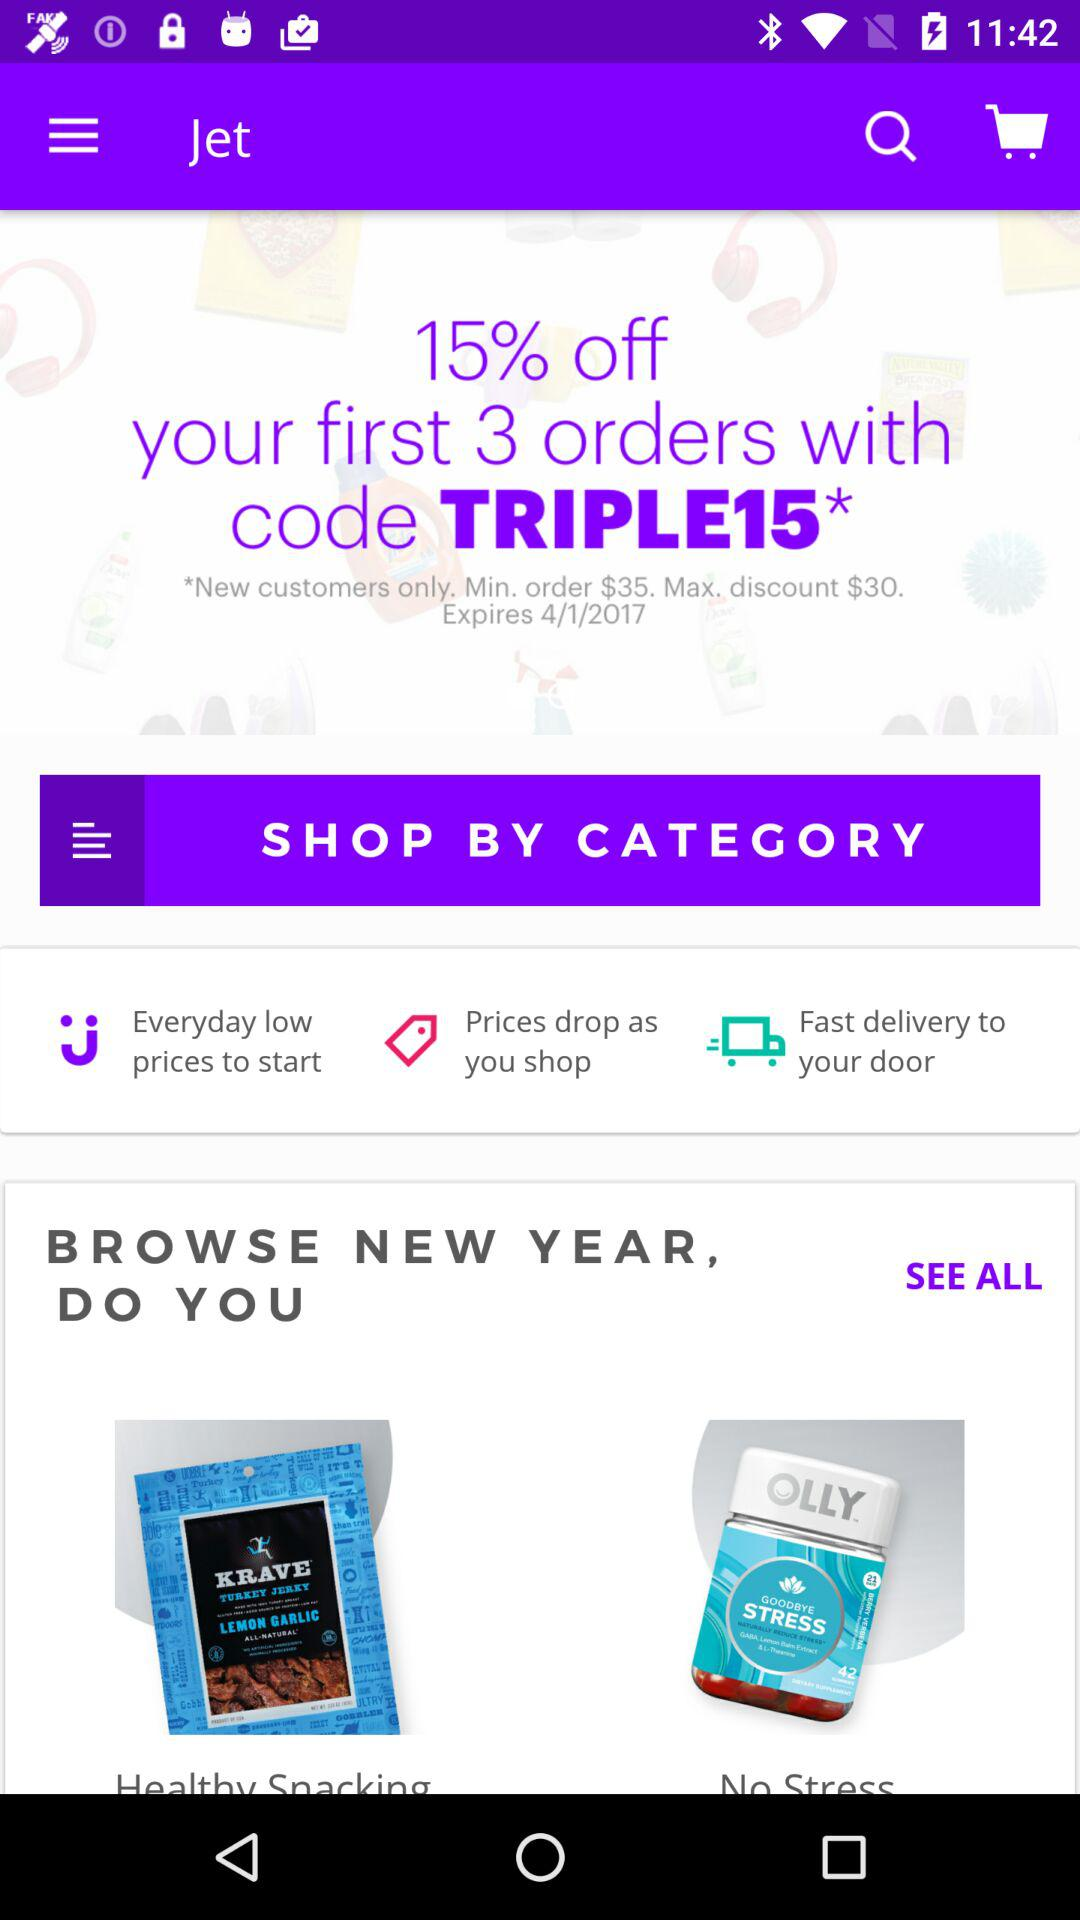The offer is valid till what date? The offer is valid till 4/1/2017. 